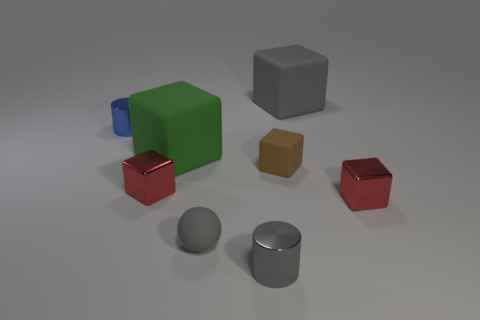What number of tiny things are either gray shiny cylinders or metal cylinders?
Provide a short and direct response. 2. There is a small matte cube; what number of tiny brown things are behind it?
Give a very brief answer. 0. Is there a tiny metallic cylinder that has the same color as the tiny sphere?
Keep it short and to the point. Yes. What shape is the green matte thing that is the same size as the gray block?
Give a very brief answer. Cube. What number of red objects are either tiny objects or matte cubes?
Your answer should be compact. 2. What number of metal objects are the same size as the green matte object?
Provide a short and direct response. 0. The tiny metal object that is the same color as the ball is what shape?
Your answer should be very brief. Cylinder. What number of objects are either small matte balls or tiny cylinders that are behind the small rubber ball?
Offer a terse response. 2. Is the size of the object in front of the rubber sphere the same as the gray matte object that is on the left side of the big gray thing?
Provide a succinct answer. Yes. What number of other small brown things are the same shape as the tiny brown object?
Make the answer very short. 0. 